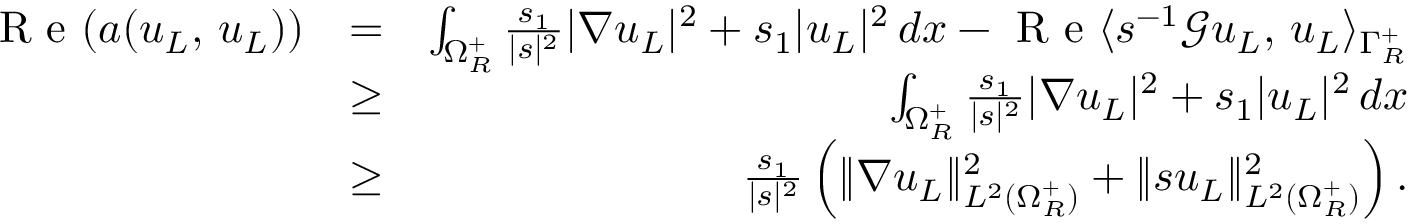<formula> <loc_0><loc_0><loc_500><loc_500>\begin{array} { r l r } { R e ( a ( u _ { L } , \, u _ { L } ) ) } & { = } & { \int _ { \Omega _ { R } ^ { + } } \frac { s _ { 1 } } { | s | ^ { 2 } } | \nabla u _ { L } | ^ { 2 } + s _ { 1 } | u _ { L } | ^ { 2 } \, d x - R e \langle s ^ { - 1 } \ m a t h s c r { G } u _ { L } , \, u _ { L } \rangle _ { \Gamma _ { R } ^ { + } } } \\ & { \geq } & { \int _ { \Omega _ { R } ^ { + } } \frac { s _ { 1 } } { | s | ^ { 2 } } | \nabla u _ { L } | ^ { 2 } + s _ { 1 } | u _ { L } | ^ { 2 } \, d x } \\ & { \geq } & { \frac { s _ { 1 } } { | s | ^ { 2 } } \left ( \| \nabla u _ { L } \| _ { L ^ { 2 } ( \Omega _ { R } ^ { + } ) } ^ { 2 } + \| s u _ { L } \| _ { L ^ { 2 } ( \Omega _ { R } ^ { + } ) } ^ { 2 } \right ) . } \end{array}</formula> 